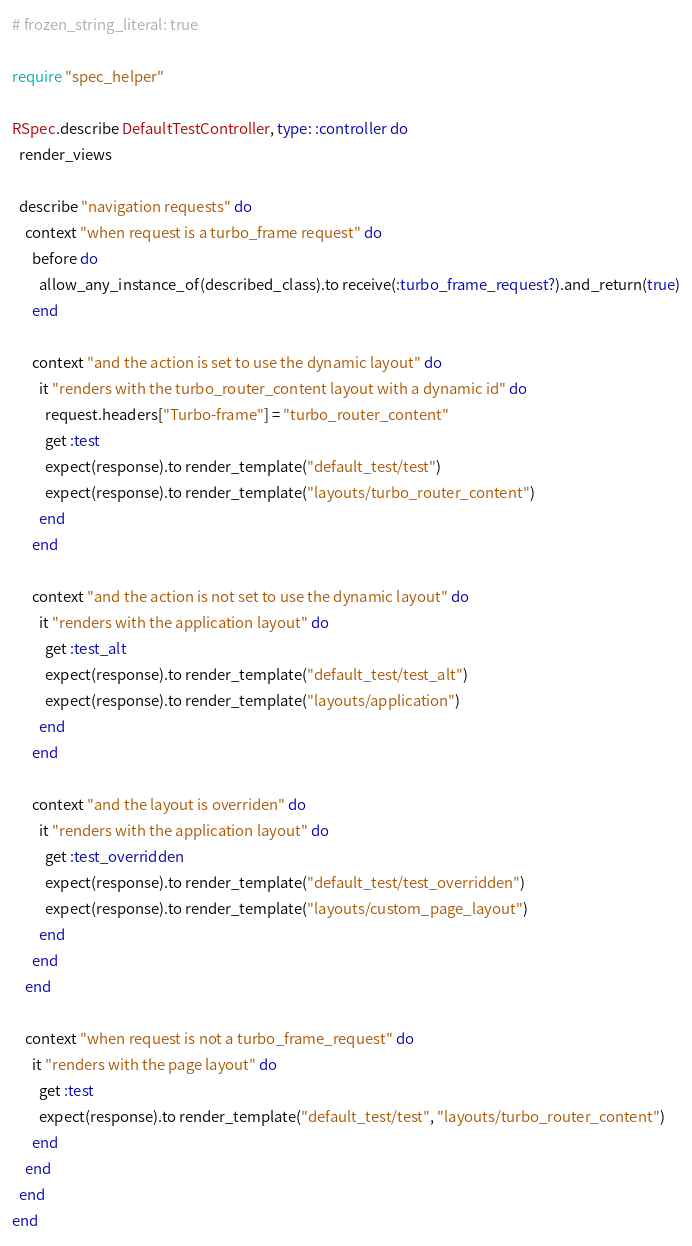<code> <loc_0><loc_0><loc_500><loc_500><_Ruby_># frozen_string_literal: true

require "spec_helper"

RSpec.describe DefaultTestController, type: :controller do
  render_views

  describe "navigation requests" do
    context "when request is a turbo_frame request" do
      before do
        allow_any_instance_of(described_class).to receive(:turbo_frame_request?).and_return(true)
      end

      context "and the action is set to use the dynamic layout" do
        it "renders with the turbo_router_content layout with a dynamic id" do
          request.headers["Turbo-frame"] = "turbo_router_content"
          get :test
          expect(response).to render_template("default_test/test")
          expect(response).to render_template("layouts/turbo_router_content")
        end
      end

      context "and the action is not set to use the dynamic layout" do
        it "renders with the application layout" do
          get :test_alt
          expect(response).to render_template("default_test/test_alt")
          expect(response).to render_template("layouts/application")
        end
      end

      context "and the layout is overriden" do
        it "renders with the application layout" do
          get :test_overridden
          expect(response).to render_template("default_test/test_overridden")
          expect(response).to render_template("layouts/custom_page_layout")
        end
      end
    end

    context "when request is not a turbo_frame_request" do
      it "renders with the page layout" do
        get :test
        expect(response).to render_template("default_test/test", "layouts/turbo_router_content")
      end
    end
  end
end
</code> 